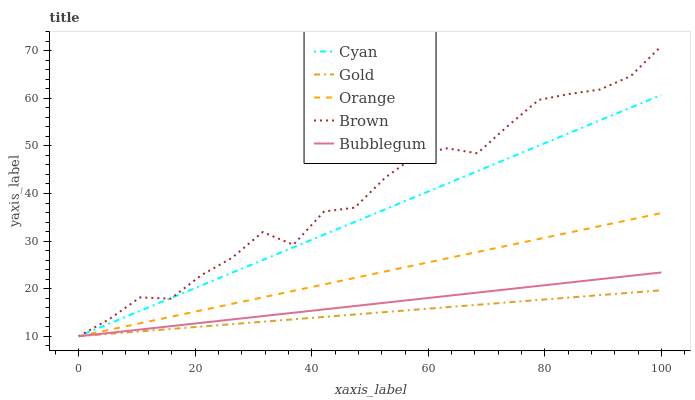Does Gold have the minimum area under the curve?
Answer yes or no. Yes. Does Brown have the maximum area under the curve?
Answer yes or no. Yes. Does Cyan have the minimum area under the curve?
Answer yes or no. No. Does Cyan have the maximum area under the curve?
Answer yes or no. No. Is Bubblegum the smoothest?
Answer yes or no. Yes. Is Brown the roughest?
Answer yes or no. Yes. Is Cyan the smoothest?
Answer yes or no. No. Is Cyan the roughest?
Answer yes or no. No. Does Orange have the lowest value?
Answer yes or no. Yes. Does Brown have the highest value?
Answer yes or no. Yes. Does Cyan have the highest value?
Answer yes or no. No. Does Gold intersect Brown?
Answer yes or no. Yes. Is Gold less than Brown?
Answer yes or no. No. Is Gold greater than Brown?
Answer yes or no. No. 